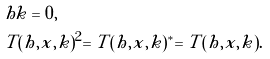<formula> <loc_0><loc_0><loc_500><loc_500>& h k = 0 , \\ & T ( h , x , k ) ^ { 2 } = T ( h , x , k ) ^ { * } = T ( h , x , k ) .</formula> 